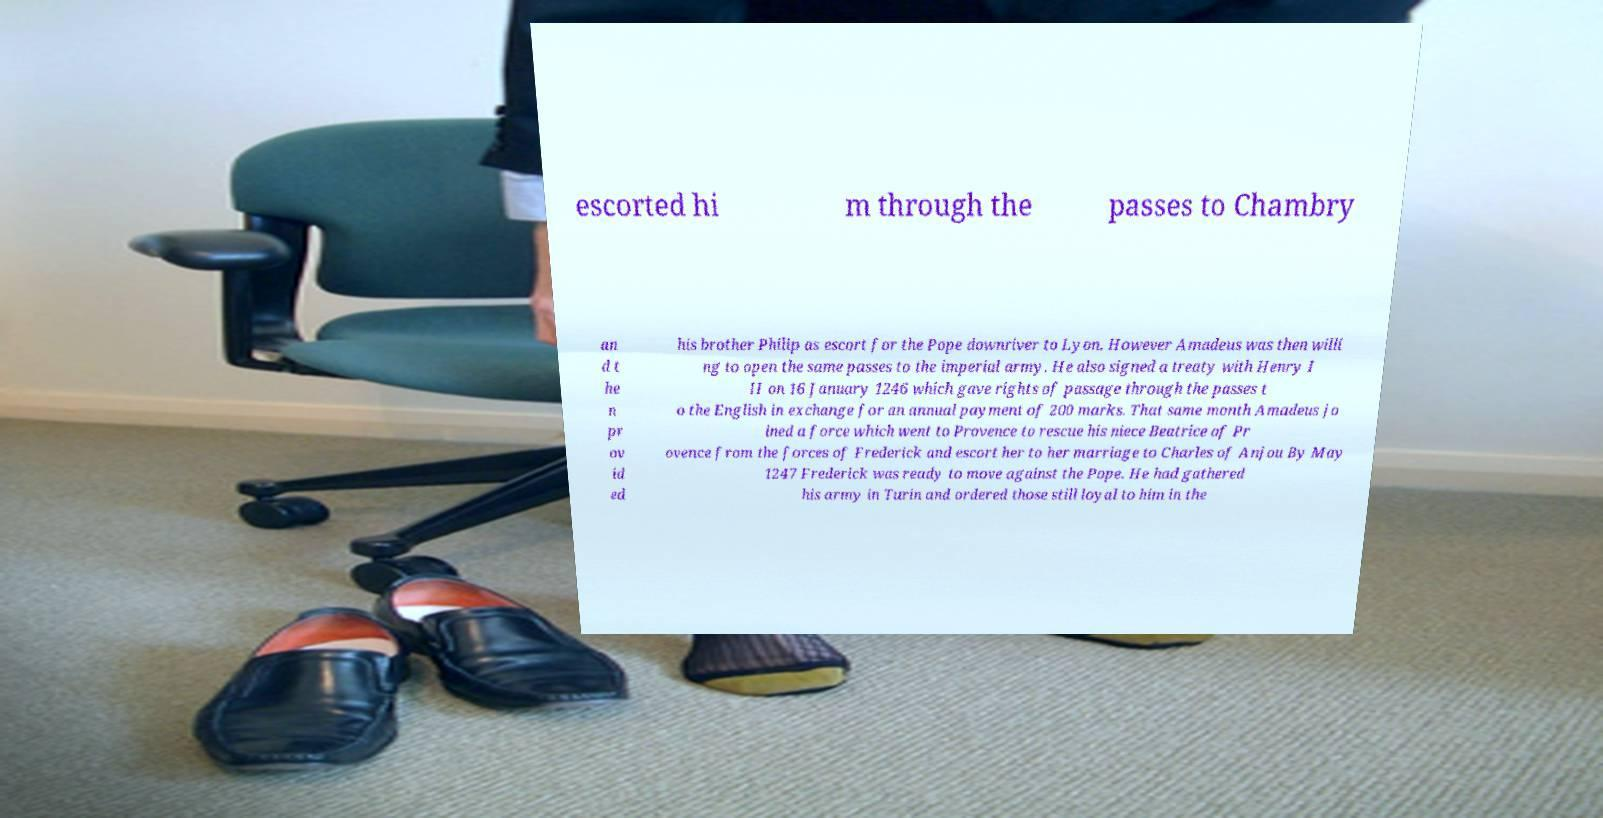For documentation purposes, I need the text within this image transcribed. Could you provide that? escorted hi m through the passes to Chambry an d t he n pr ov id ed his brother Philip as escort for the Pope downriver to Lyon. However Amadeus was then willi ng to open the same passes to the imperial army. He also signed a treaty with Henry I II on 16 January 1246 which gave rights of passage through the passes t o the English in exchange for an annual payment of 200 marks. That same month Amadeus jo ined a force which went to Provence to rescue his niece Beatrice of Pr ovence from the forces of Frederick and escort her to her marriage to Charles of Anjou By May 1247 Frederick was ready to move against the Pope. He had gathered his army in Turin and ordered those still loyal to him in the 